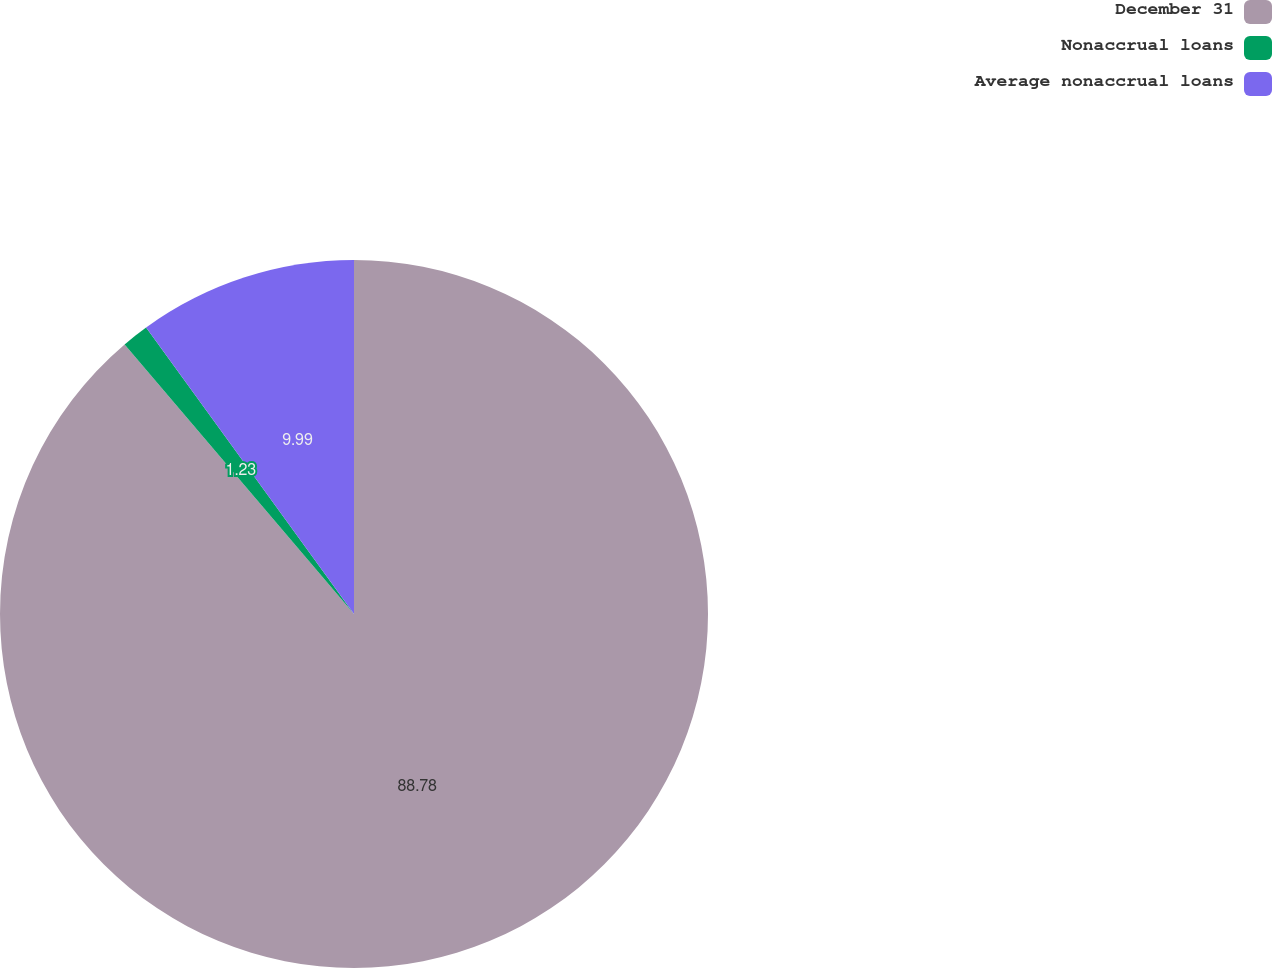Convert chart to OTSL. <chart><loc_0><loc_0><loc_500><loc_500><pie_chart><fcel>December 31<fcel>Nonaccrual loans<fcel>Average nonaccrual loans<nl><fcel>88.78%<fcel>1.23%<fcel>9.99%<nl></chart> 